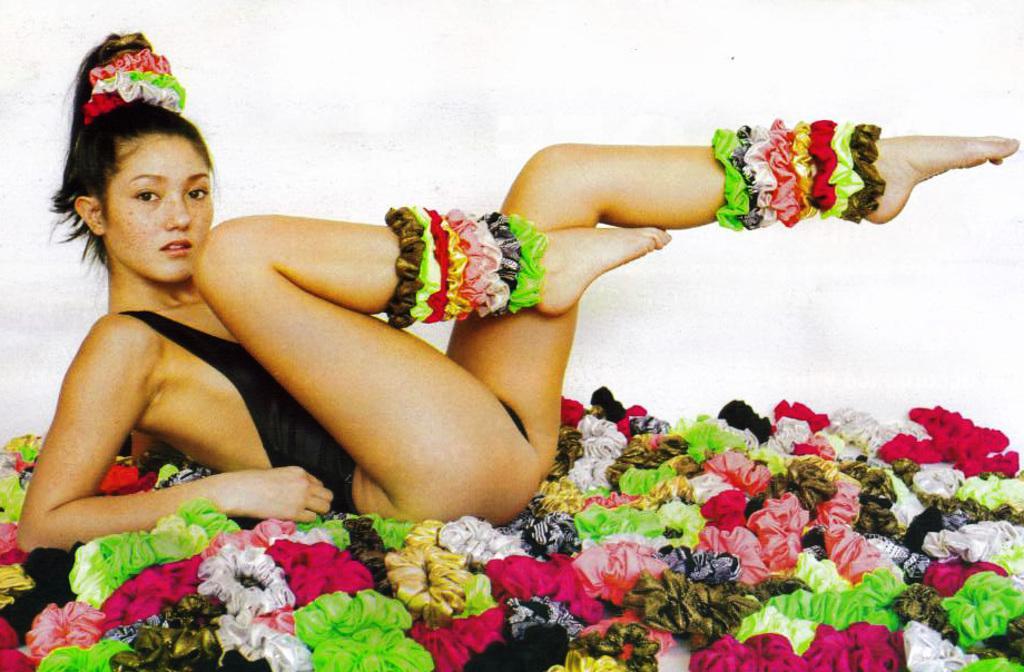How would you summarize this image in a sentence or two? In this image there is a woman lying on the floor with hair bands. In the background of the image there is a wall. 